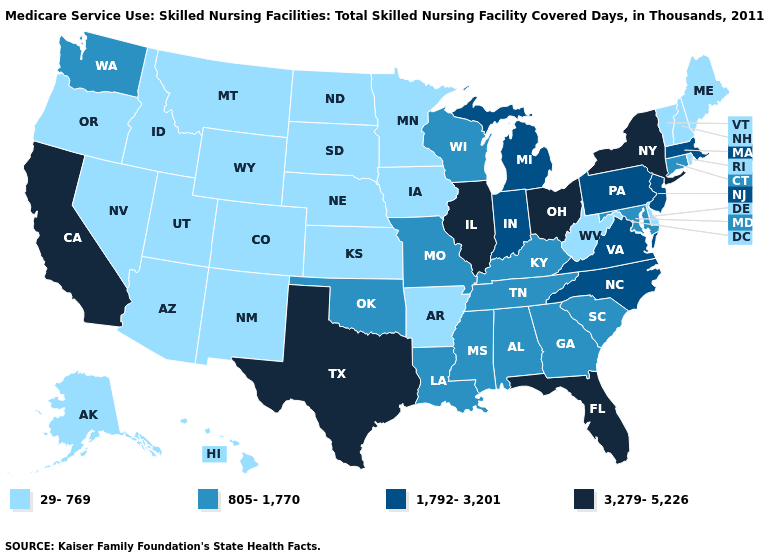What is the value of Nevada?
Answer briefly. 29-769. Name the states that have a value in the range 29-769?
Keep it brief. Alaska, Arizona, Arkansas, Colorado, Delaware, Hawaii, Idaho, Iowa, Kansas, Maine, Minnesota, Montana, Nebraska, Nevada, New Hampshire, New Mexico, North Dakota, Oregon, Rhode Island, South Dakota, Utah, Vermont, West Virginia, Wyoming. Name the states that have a value in the range 1,792-3,201?
Write a very short answer. Indiana, Massachusetts, Michigan, New Jersey, North Carolina, Pennsylvania, Virginia. Does the first symbol in the legend represent the smallest category?
Quick response, please. Yes. What is the value of Montana?
Write a very short answer. 29-769. Name the states that have a value in the range 805-1,770?
Concise answer only. Alabama, Connecticut, Georgia, Kentucky, Louisiana, Maryland, Mississippi, Missouri, Oklahoma, South Carolina, Tennessee, Washington, Wisconsin. What is the value of West Virginia?
Keep it brief. 29-769. What is the value of Utah?
Give a very brief answer. 29-769. What is the highest value in the USA?
Be succinct. 3,279-5,226. What is the lowest value in the USA?
Be succinct. 29-769. Does Pennsylvania have the lowest value in the Northeast?
Concise answer only. No. Does Kentucky have a lower value than Connecticut?
Answer briefly. No. Name the states that have a value in the range 805-1,770?
Keep it brief. Alabama, Connecticut, Georgia, Kentucky, Louisiana, Maryland, Mississippi, Missouri, Oklahoma, South Carolina, Tennessee, Washington, Wisconsin. What is the lowest value in states that border Louisiana?
Answer briefly. 29-769. Which states have the lowest value in the West?
Concise answer only. Alaska, Arizona, Colorado, Hawaii, Idaho, Montana, Nevada, New Mexico, Oregon, Utah, Wyoming. 